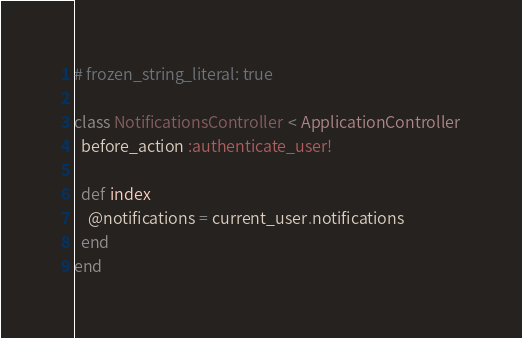<code> <loc_0><loc_0><loc_500><loc_500><_Ruby_># frozen_string_literal: true

class NotificationsController < ApplicationController
  before_action :authenticate_user!

  def index
    @notifications = current_user.notifications
  end
end
</code> 